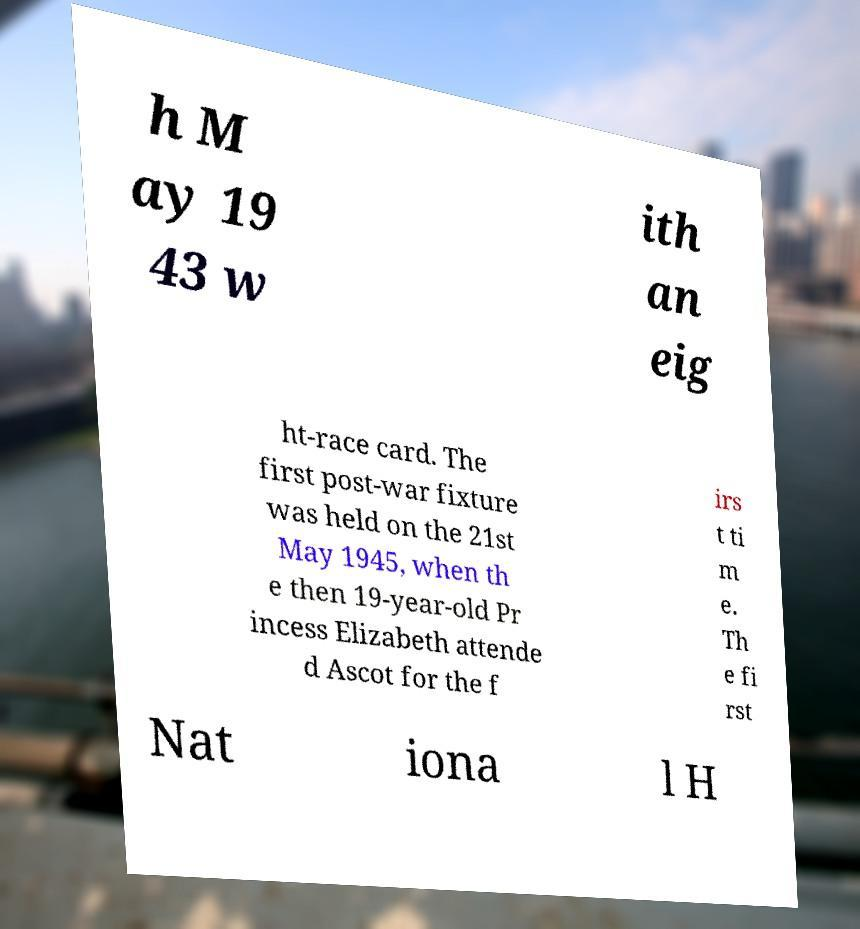Could you assist in decoding the text presented in this image and type it out clearly? h M ay 19 43 w ith an eig ht-race card. The first post-war fixture was held on the 21st May 1945, when th e then 19-year-old Pr incess Elizabeth attende d Ascot for the f irs t ti m e. Th e fi rst Nat iona l H 